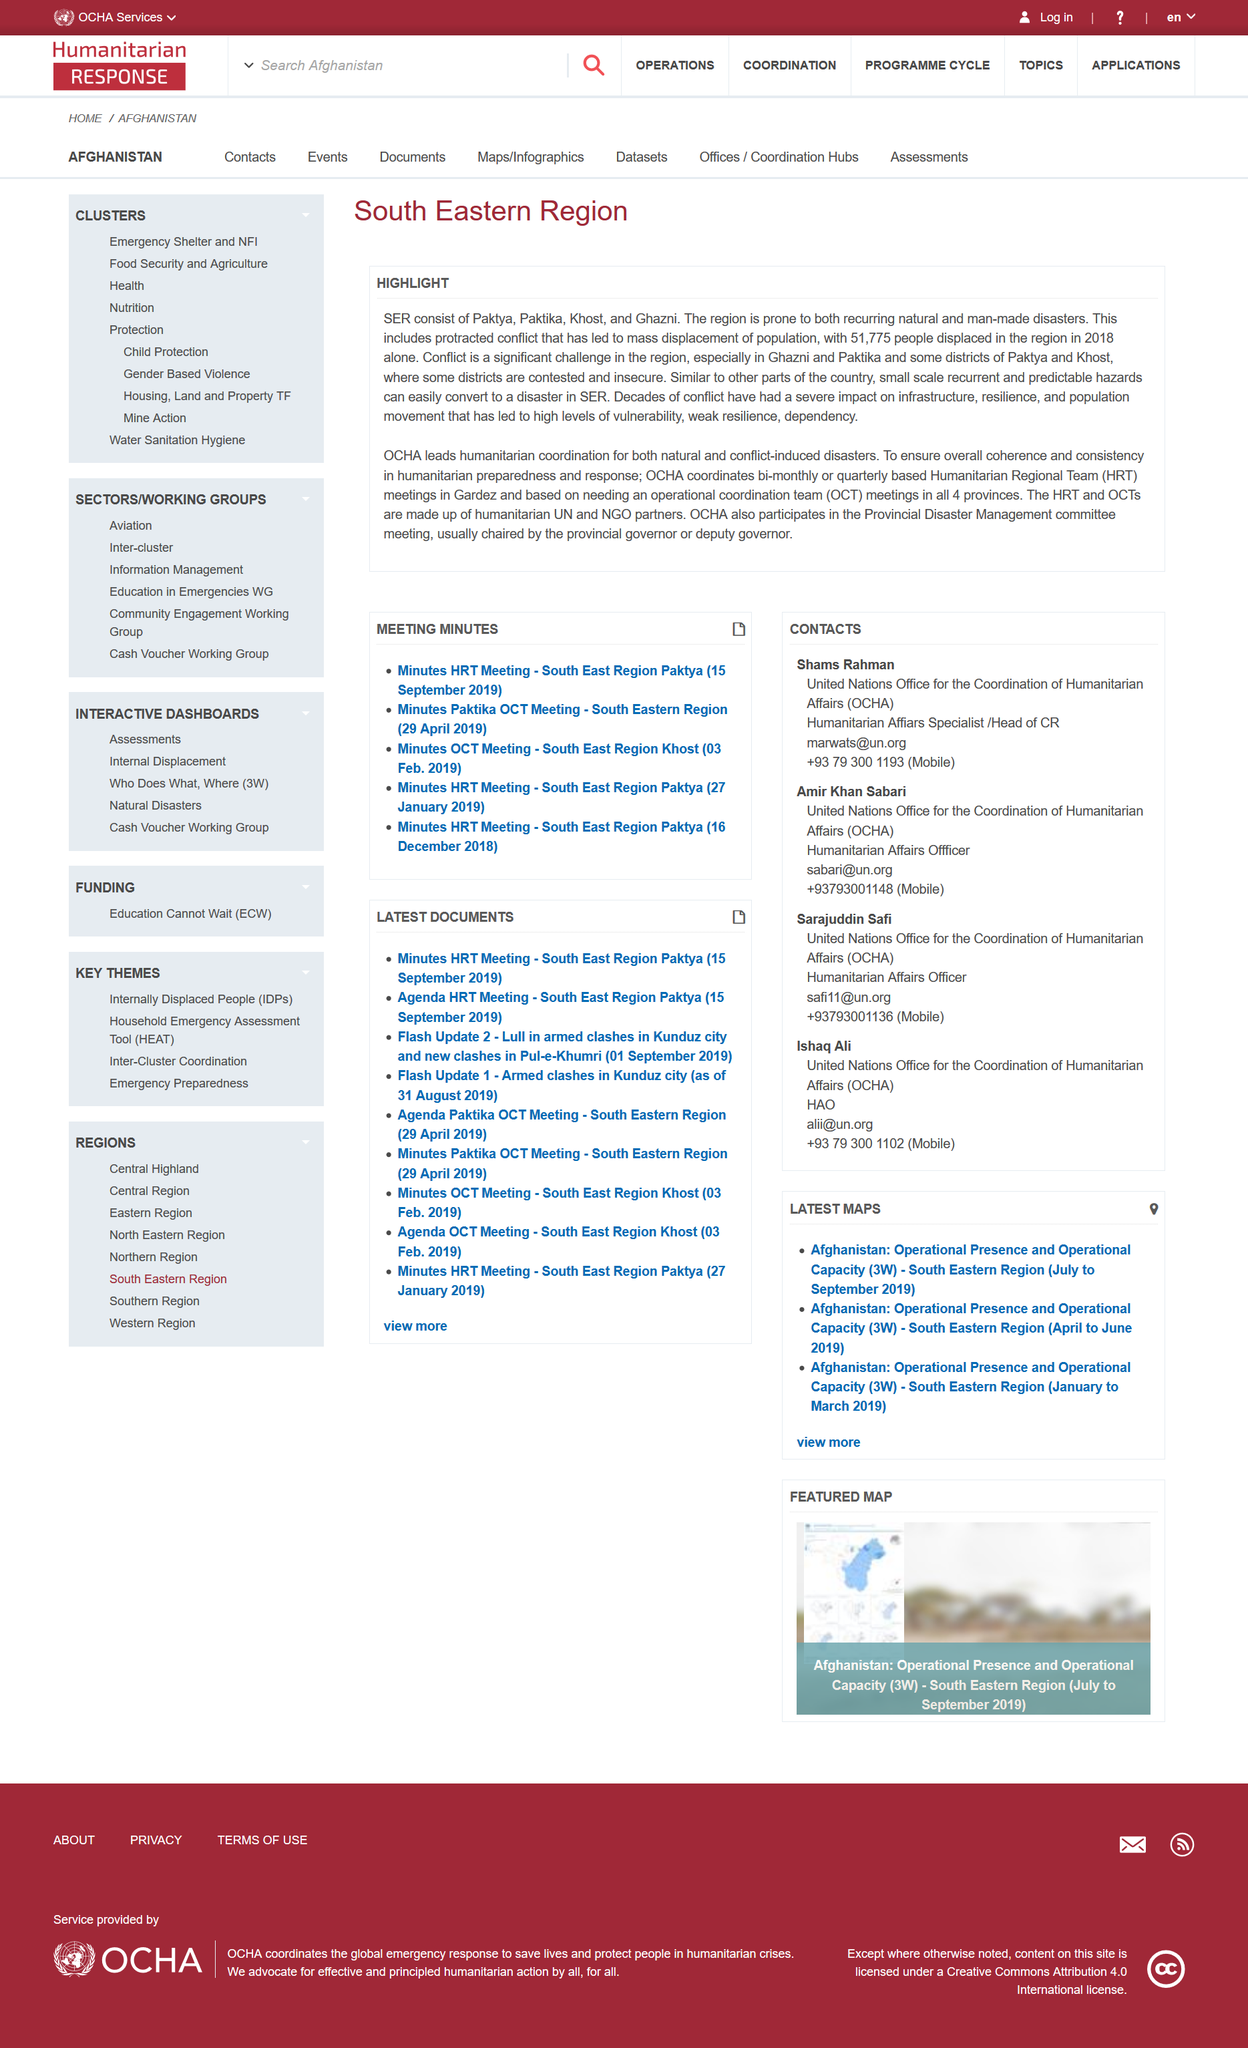List a handful of essential elements in this visual. The SER includes the provinces of Paktika, Paktya, Khost, and Ghazni. In 2018, a total of 51,775 people were displaced in the region due to various factors such as natural disasters, conflicts, and economic hardships. The acronym "SER" stands for South Eastern Region. 